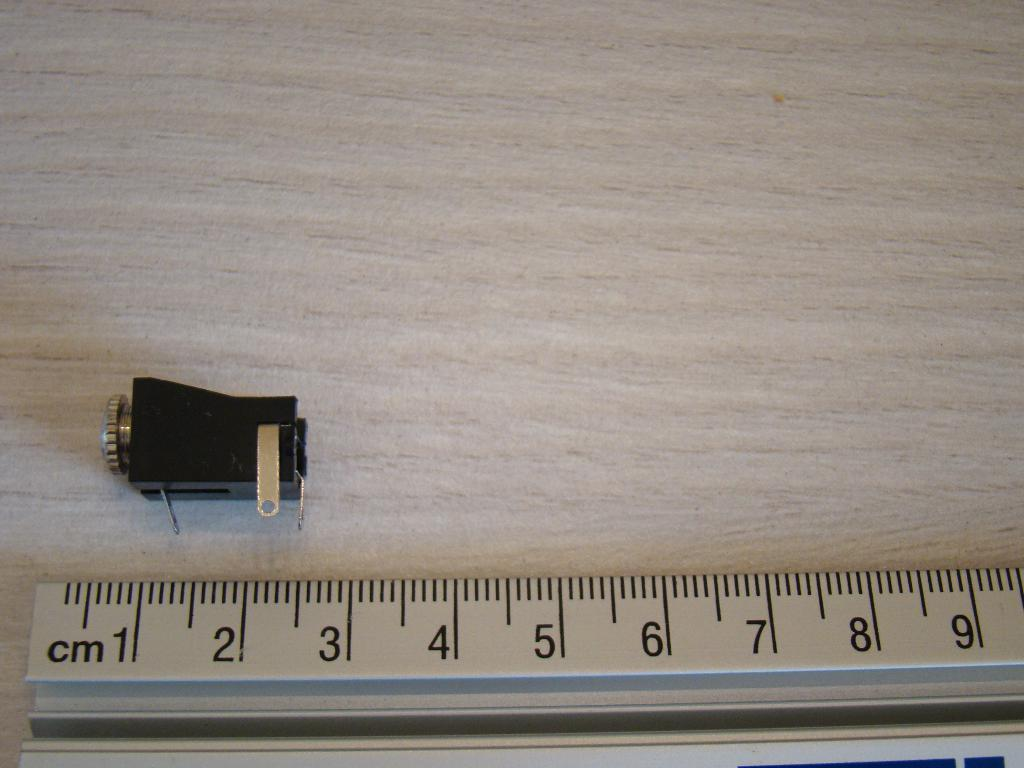<image>
Describe the image concisely. A black gadget is laid above a ruler marked with centimeters that shows it is approximately 2cm long. 